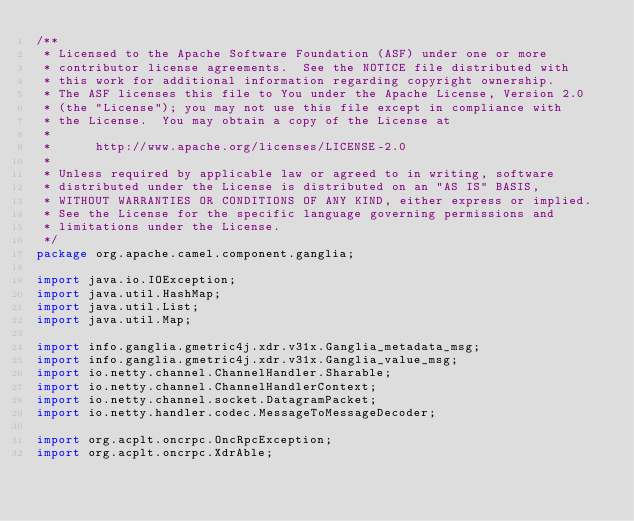Convert code to text. <code><loc_0><loc_0><loc_500><loc_500><_Java_>/**
 * Licensed to the Apache Software Foundation (ASF) under one or more
 * contributor license agreements.  See the NOTICE file distributed with
 * this work for additional information regarding copyright ownership.
 * The ASF licenses this file to You under the Apache License, Version 2.0
 * (the "License"); you may not use this file except in compliance with
 * the License.  You may obtain a copy of the License at
 *
 *      http://www.apache.org/licenses/LICENSE-2.0
 *
 * Unless required by applicable law or agreed to in writing, software
 * distributed under the License is distributed on an "AS IS" BASIS,
 * WITHOUT WARRANTIES OR CONDITIONS OF ANY KIND, either express or implied.
 * See the License for the specific language governing permissions and
 * limitations under the License.
 */
package org.apache.camel.component.ganglia;

import java.io.IOException;
import java.util.HashMap;
import java.util.List;
import java.util.Map;

import info.ganglia.gmetric4j.xdr.v31x.Ganglia_metadata_msg;
import info.ganglia.gmetric4j.xdr.v31x.Ganglia_value_msg;
import io.netty.channel.ChannelHandler.Sharable;
import io.netty.channel.ChannelHandlerContext;
import io.netty.channel.socket.DatagramPacket;
import io.netty.handler.codec.MessageToMessageDecoder;

import org.acplt.oncrpc.OncRpcException;
import org.acplt.oncrpc.XdrAble;</code> 